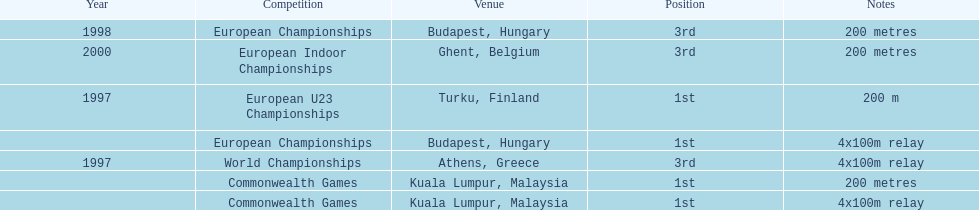How many competitions were in budapest, hungary and came in 1st position? 1. 